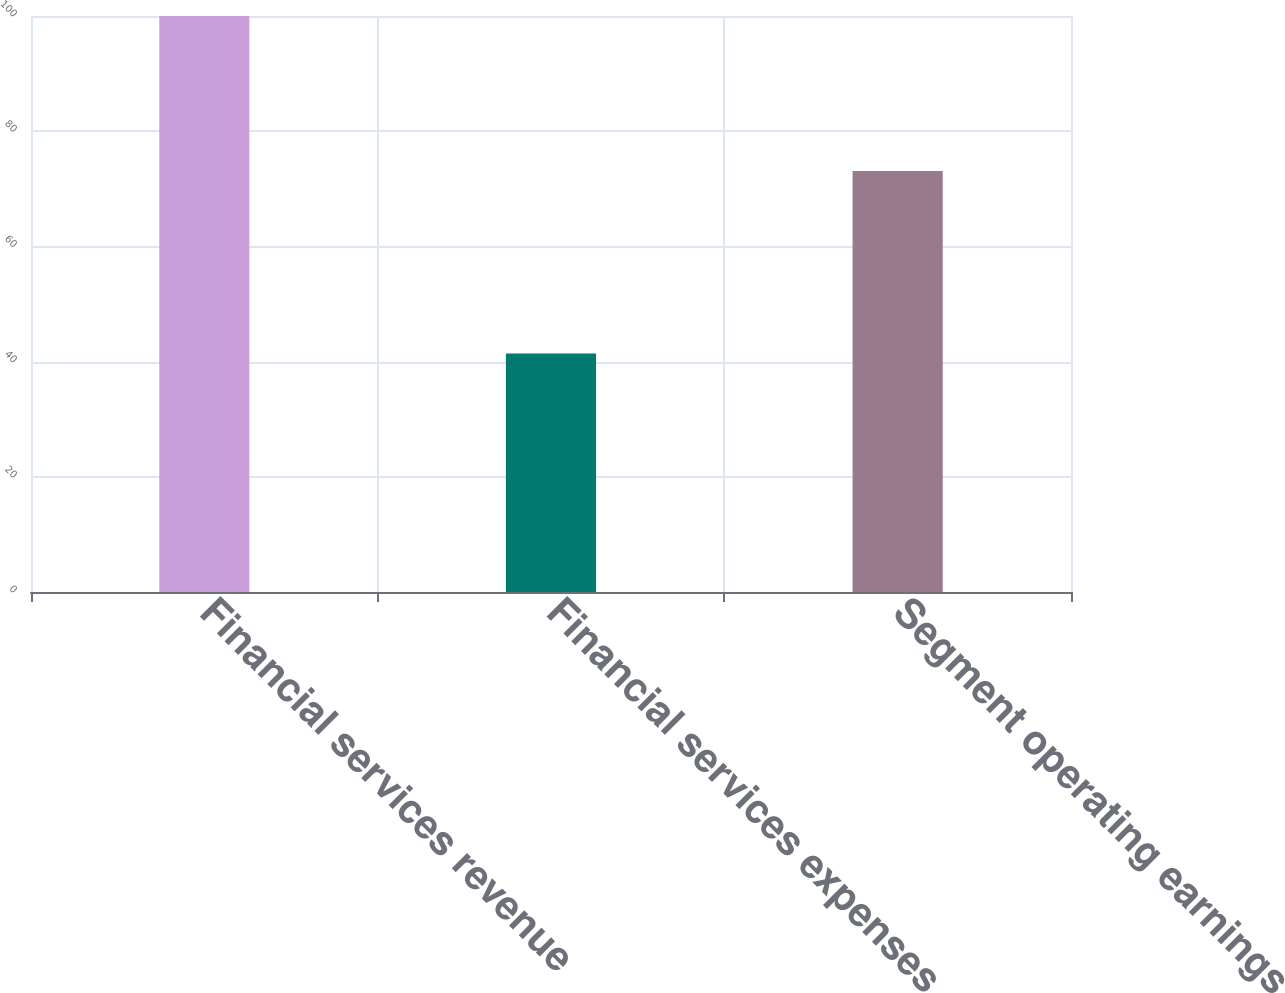Convert chart to OTSL. <chart><loc_0><loc_0><loc_500><loc_500><bar_chart><fcel>Financial services revenue<fcel>Financial services expenses<fcel>Segment operating earnings<nl><fcel>100<fcel>41.4<fcel>73.1<nl></chart> 